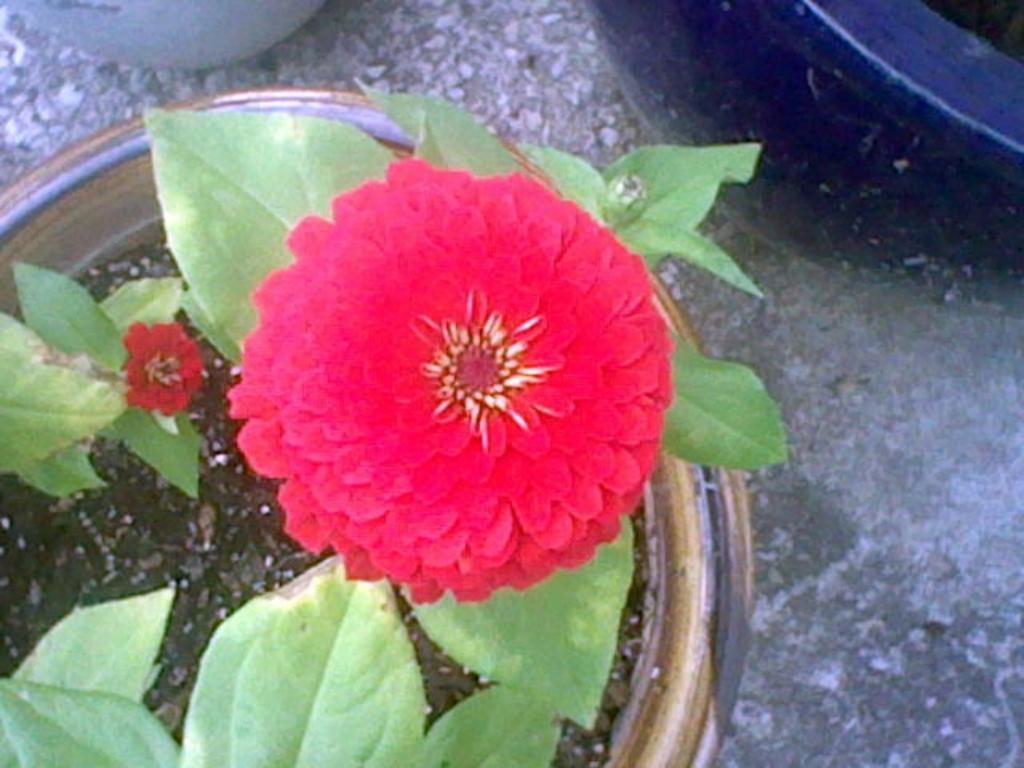Can you describe this image briefly? In pot we can see the plant and red flowers. In the top right corner there is a black object. At the top there is a white pot which is kept on the floor. 